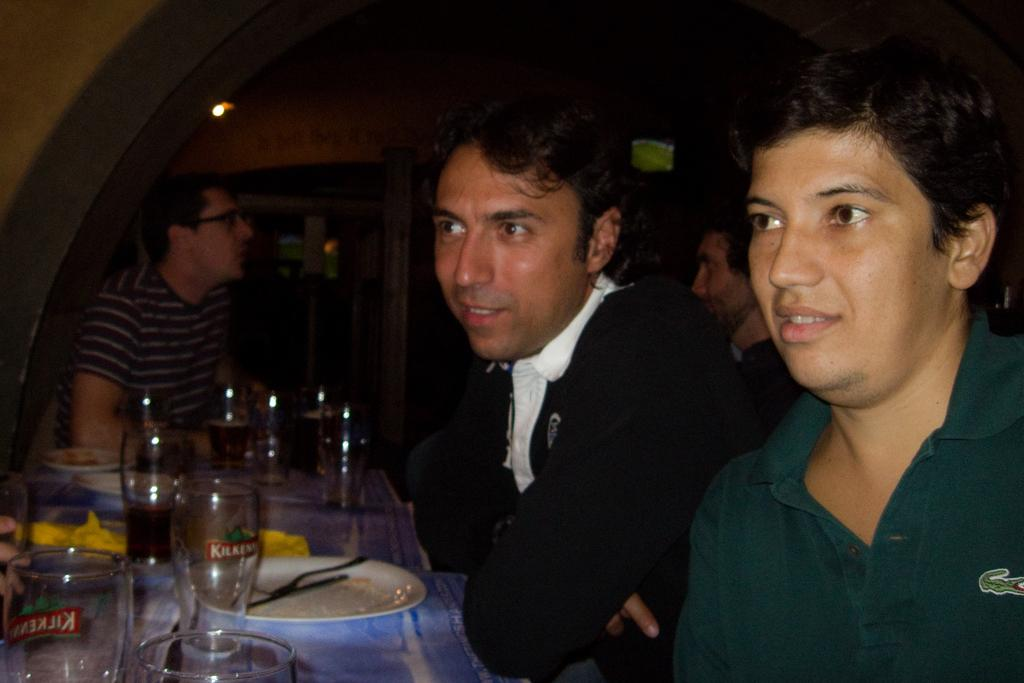What is happening around the table in the image? There are people around the table in the image. What can be seen on the table? There are plates and bottles on the table, as well as other objects. Can you describe the light in the image? There is a light attached to the wall in the image. Are there any giants present in the image? No, there are no giants present in the image. Is the atmosphere around the table harmonious? The image does not provide information about the atmosphere or emotions of the people around the table, so we cannot determine if it is harmonious or not. 